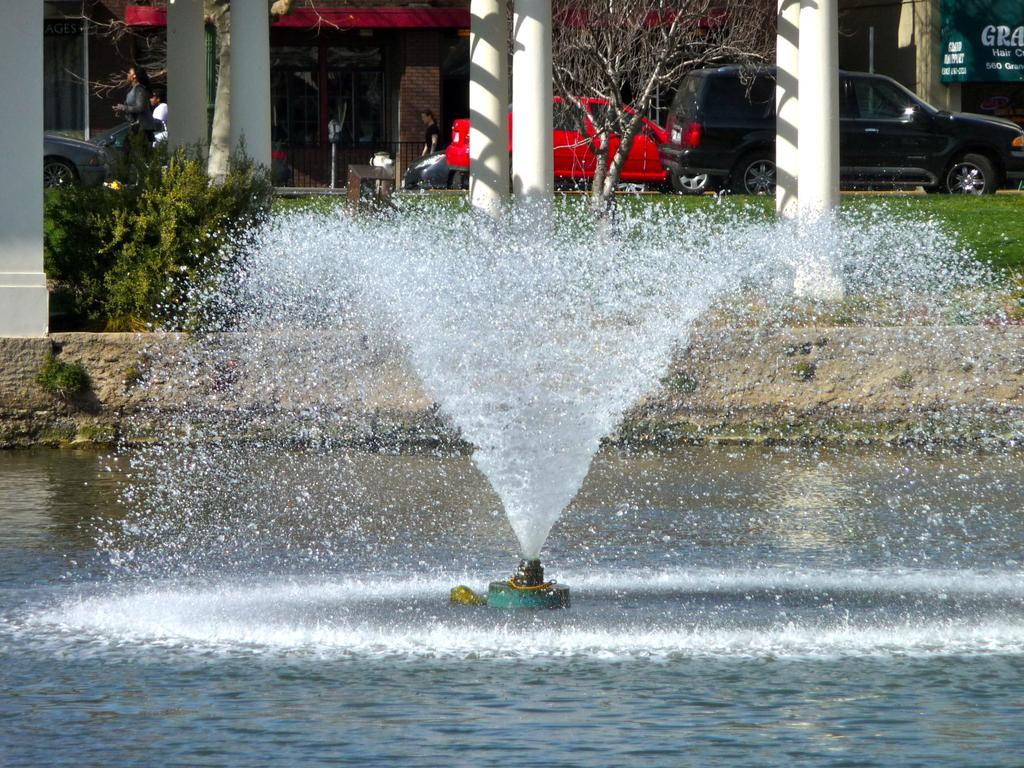What is the main feature in the image? There is a water fountain in the image. What can be seen in the background of the image? In the background, there are pillars, plants, grass, trees, vehicles, houses, and a banner. Are there any living beings visible in the image? Yes, there are people visible in the image. What type of seed is being planted by the people in the image? There is no indication in the image that people are planting seeds or engaging in any gardening activities. 